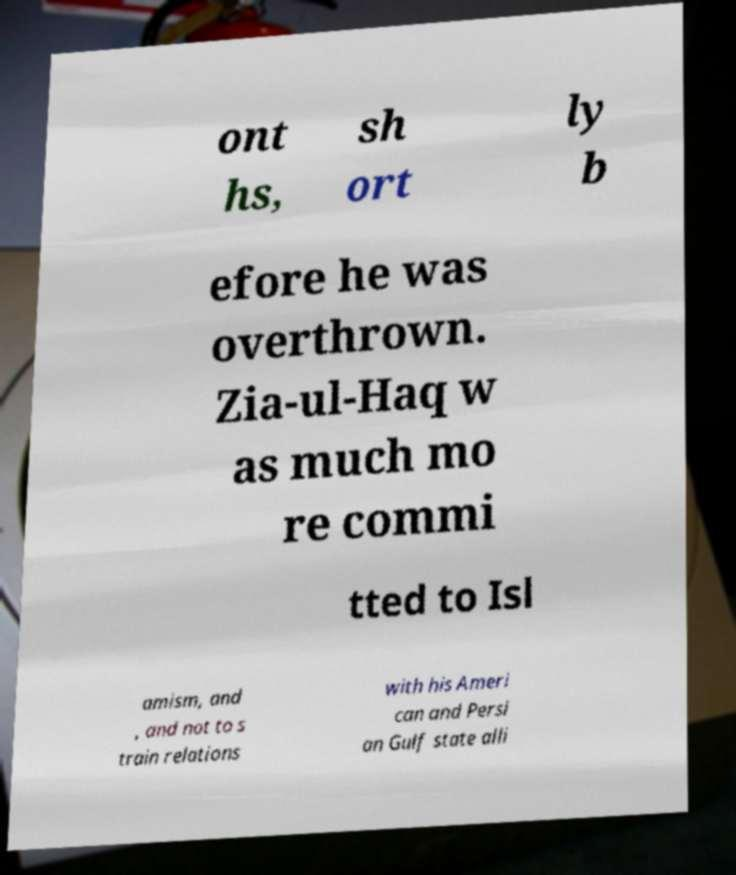Can you accurately transcribe the text from the provided image for me? ont hs, sh ort ly b efore he was overthrown. Zia-ul-Haq w as much mo re commi tted to Isl amism, and , and not to s train relations with his Ameri can and Persi an Gulf state alli 